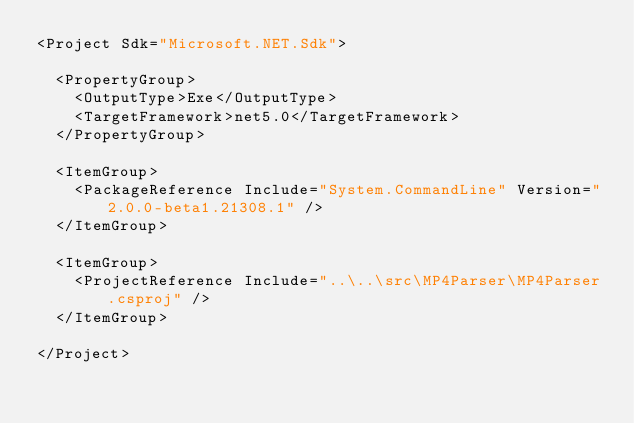Convert code to text. <code><loc_0><loc_0><loc_500><loc_500><_XML_><Project Sdk="Microsoft.NET.Sdk">

  <PropertyGroup>
    <OutputType>Exe</OutputType>
    <TargetFramework>net5.0</TargetFramework>
  </PropertyGroup>

  <ItemGroup>
    <PackageReference Include="System.CommandLine" Version="2.0.0-beta1.21308.1" />
  </ItemGroup>

  <ItemGroup>
    <ProjectReference Include="..\..\src\MP4Parser\MP4Parser.csproj" />
  </ItemGroup>

</Project>
</code> 